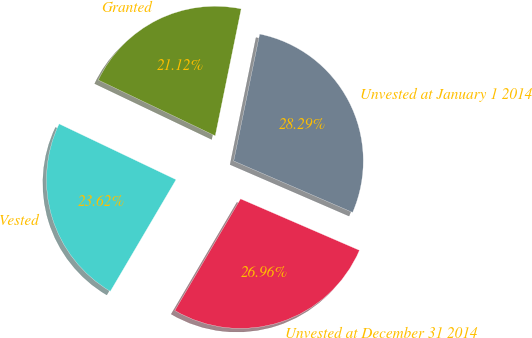Convert chart. <chart><loc_0><loc_0><loc_500><loc_500><pie_chart><fcel>Unvested at January 1 2014<fcel>Granted<fcel>Vested<fcel>Unvested at December 31 2014<nl><fcel>28.29%<fcel>21.12%<fcel>23.62%<fcel>26.96%<nl></chart> 